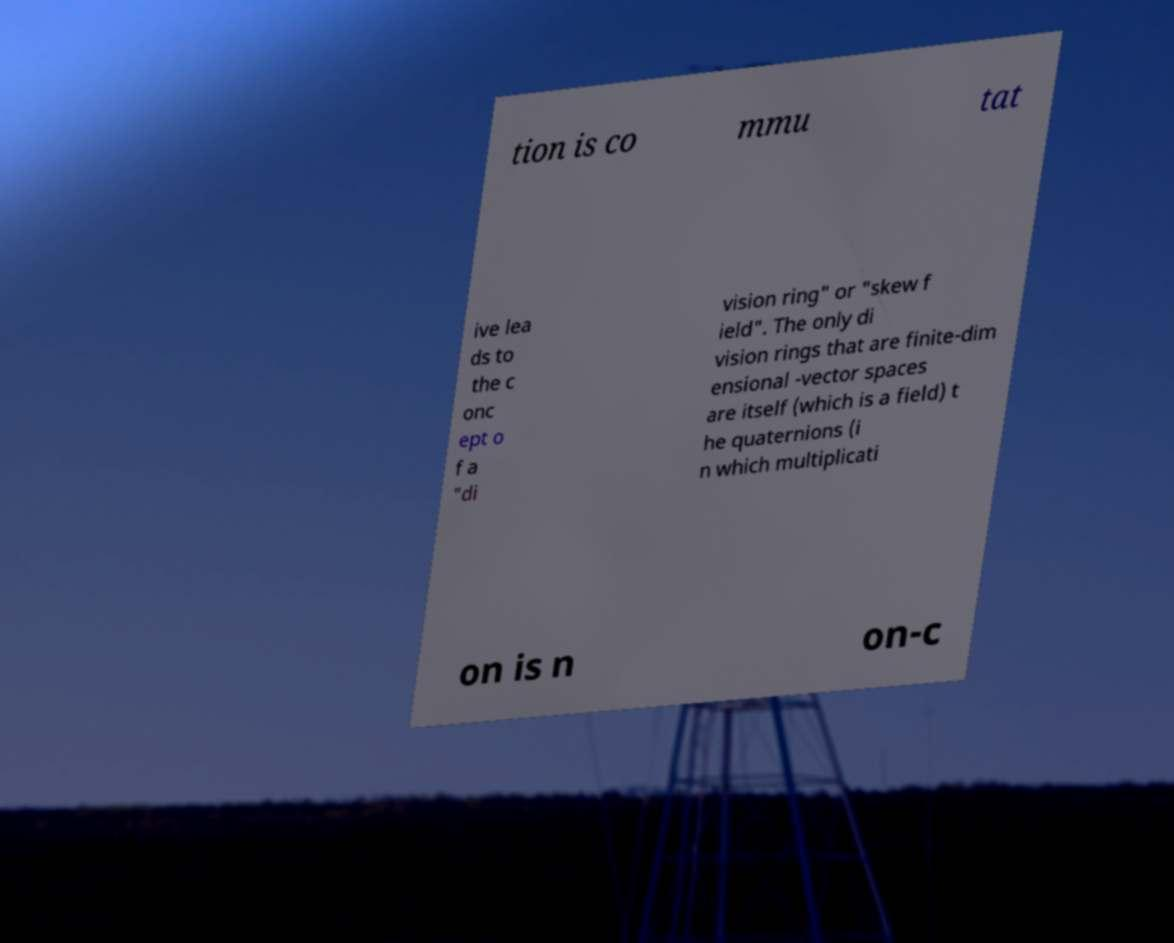Can you read and provide the text displayed in the image?This photo seems to have some interesting text. Can you extract and type it out for me? tion is co mmu tat ive lea ds to the c onc ept o f a "di vision ring" or "skew f ield". The only di vision rings that are finite-dim ensional -vector spaces are itself (which is a field) t he quaternions (i n which multiplicati on is n on-c 